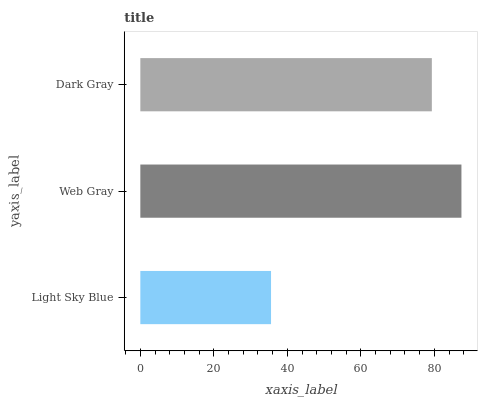Is Light Sky Blue the minimum?
Answer yes or no. Yes. Is Web Gray the maximum?
Answer yes or no. Yes. Is Dark Gray the minimum?
Answer yes or no. No. Is Dark Gray the maximum?
Answer yes or no. No. Is Web Gray greater than Dark Gray?
Answer yes or no. Yes. Is Dark Gray less than Web Gray?
Answer yes or no. Yes. Is Dark Gray greater than Web Gray?
Answer yes or no. No. Is Web Gray less than Dark Gray?
Answer yes or no. No. Is Dark Gray the high median?
Answer yes or no. Yes. Is Dark Gray the low median?
Answer yes or no. Yes. Is Web Gray the high median?
Answer yes or no. No. Is Light Sky Blue the low median?
Answer yes or no. No. 